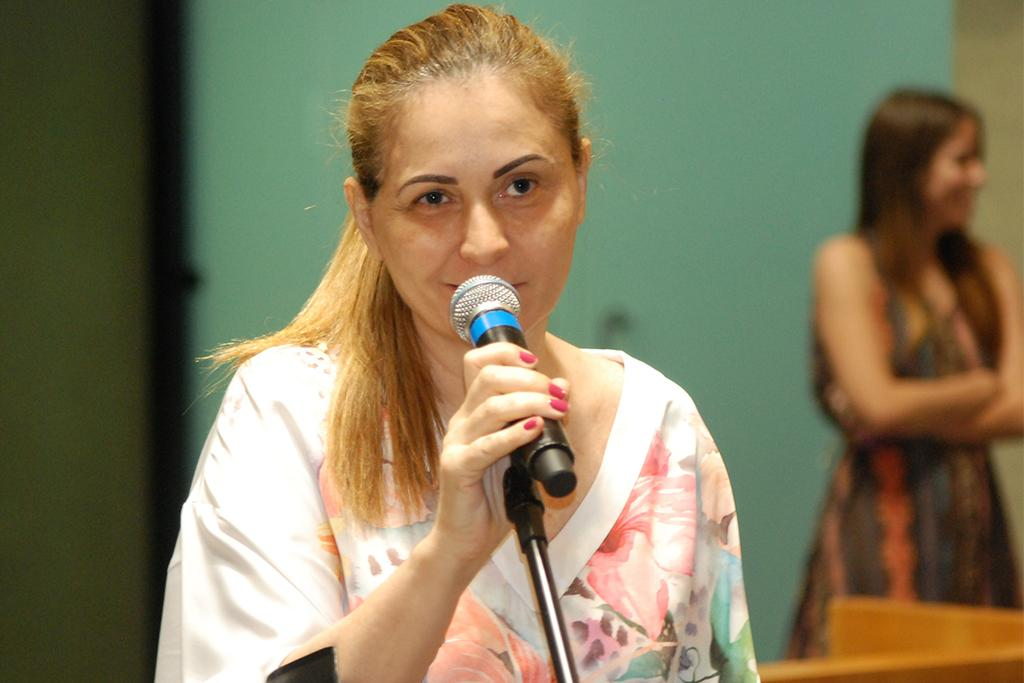How many people are present in the image? There are two people in the image. Can you describe one of the individuals in the image? One of the people is a woman. What is the woman holding in her hand? The woman is holding a mic in her hand. What type of skin is visible on the mic in the image? The mic does not have skin; it is an electronic device. 